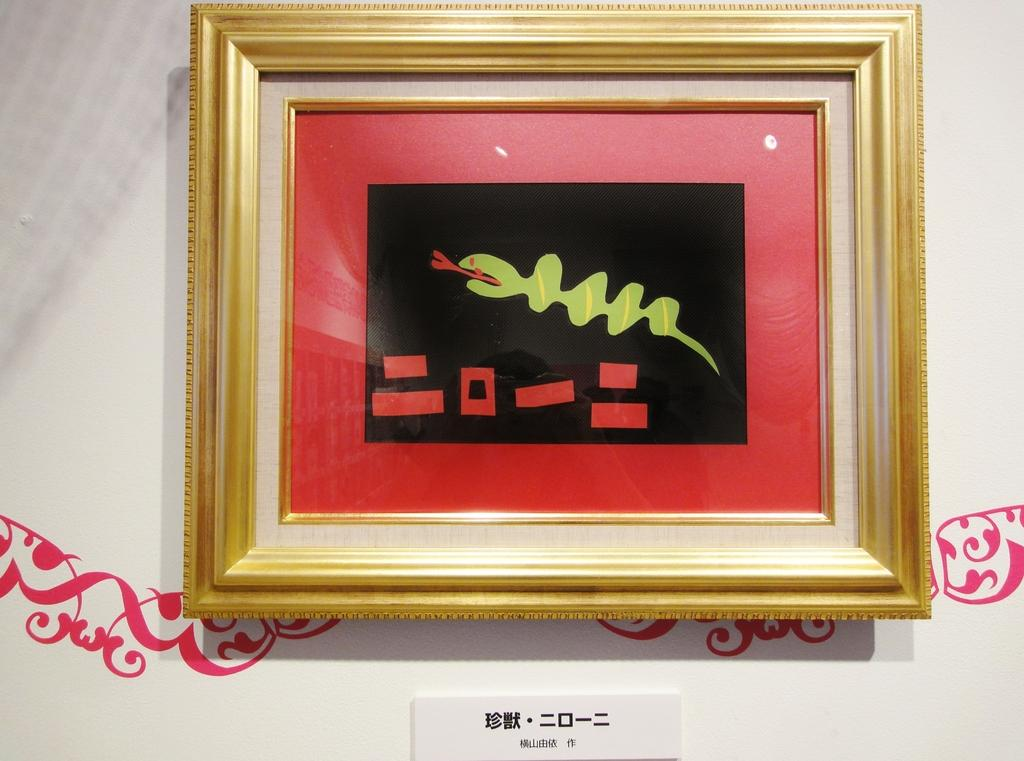What is on the wall in the image? There is a frame on the wall in the image. How many beds are visible in the image? There are no beds present in the image; it only features a frame on the wall. What type of stick can be seen in the image? There is no stick present in the image. 